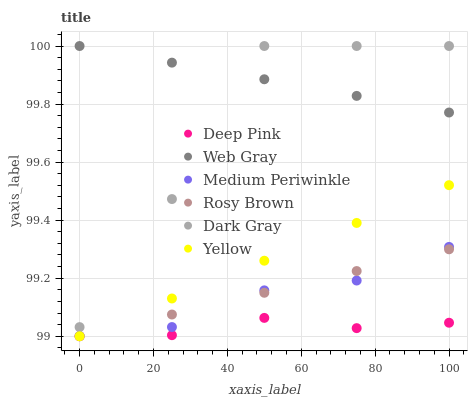Does Deep Pink have the minimum area under the curve?
Answer yes or no. Yes. Does Web Gray have the maximum area under the curve?
Answer yes or no. Yes. Does Rosy Brown have the minimum area under the curve?
Answer yes or no. No. Does Rosy Brown have the maximum area under the curve?
Answer yes or no. No. Is Web Gray the smoothest?
Answer yes or no. Yes. Is Dark Gray the roughest?
Answer yes or no. Yes. Is Rosy Brown the smoothest?
Answer yes or no. No. Is Rosy Brown the roughest?
Answer yes or no. No. Does Deep Pink have the lowest value?
Answer yes or no. Yes. Does Medium Periwinkle have the lowest value?
Answer yes or no. No. Does Web Gray have the highest value?
Answer yes or no. Yes. Does Rosy Brown have the highest value?
Answer yes or no. No. Is Rosy Brown less than Web Gray?
Answer yes or no. Yes. Is Web Gray greater than Rosy Brown?
Answer yes or no. Yes. Does Rosy Brown intersect Deep Pink?
Answer yes or no. Yes. Is Rosy Brown less than Deep Pink?
Answer yes or no. No. Is Rosy Brown greater than Deep Pink?
Answer yes or no. No. Does Rosy Brown intersect Web Gray?
Answer yes or no. No. 